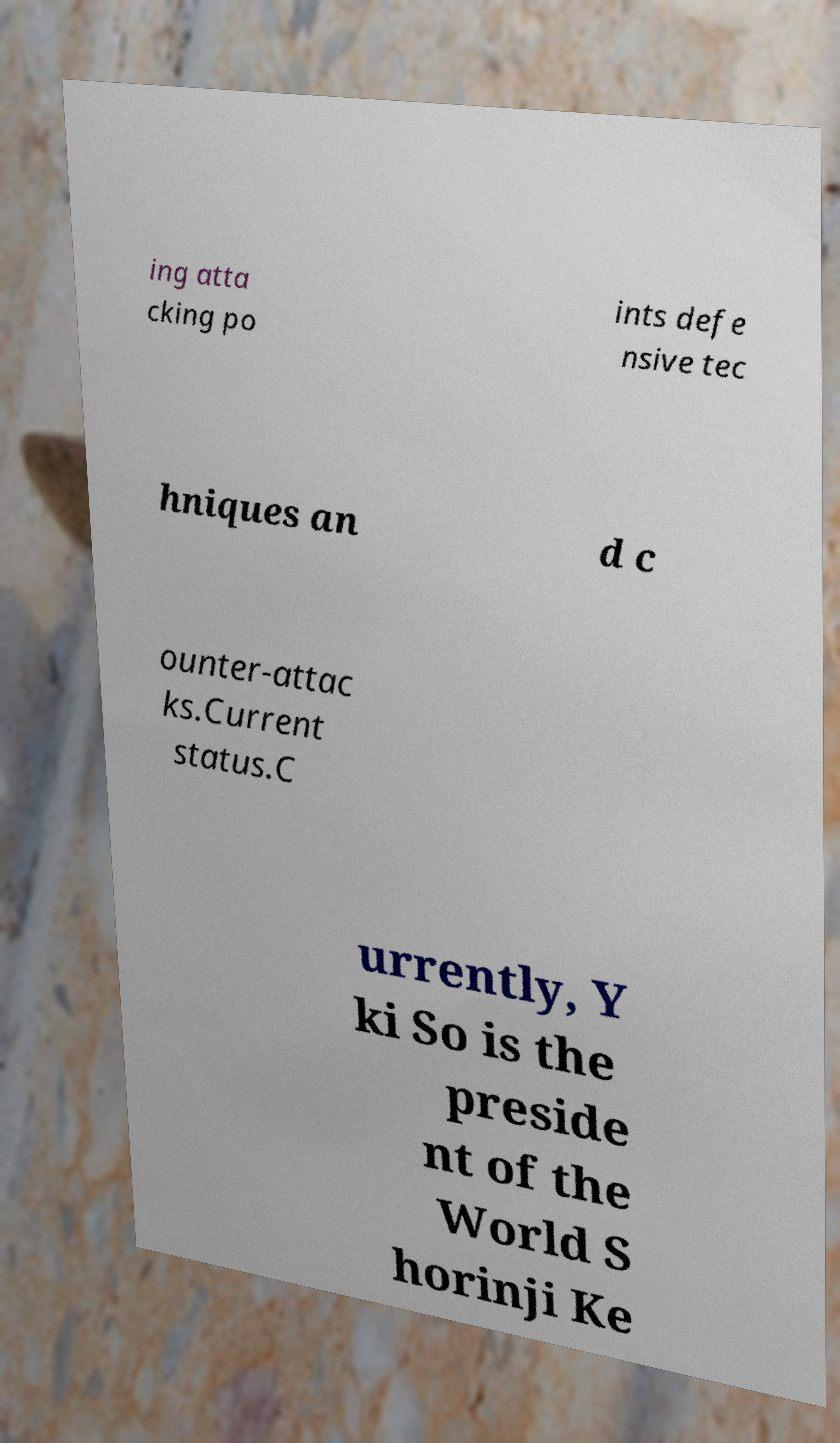For documentation purposes, I need the text within this image transcribed. Could you provide that? ing atta cking po ints defe nsive tec hniques an d c ounter-attac ks.Current status.C urrently, Y ki So is the preside nt of the World S horinji Ke 